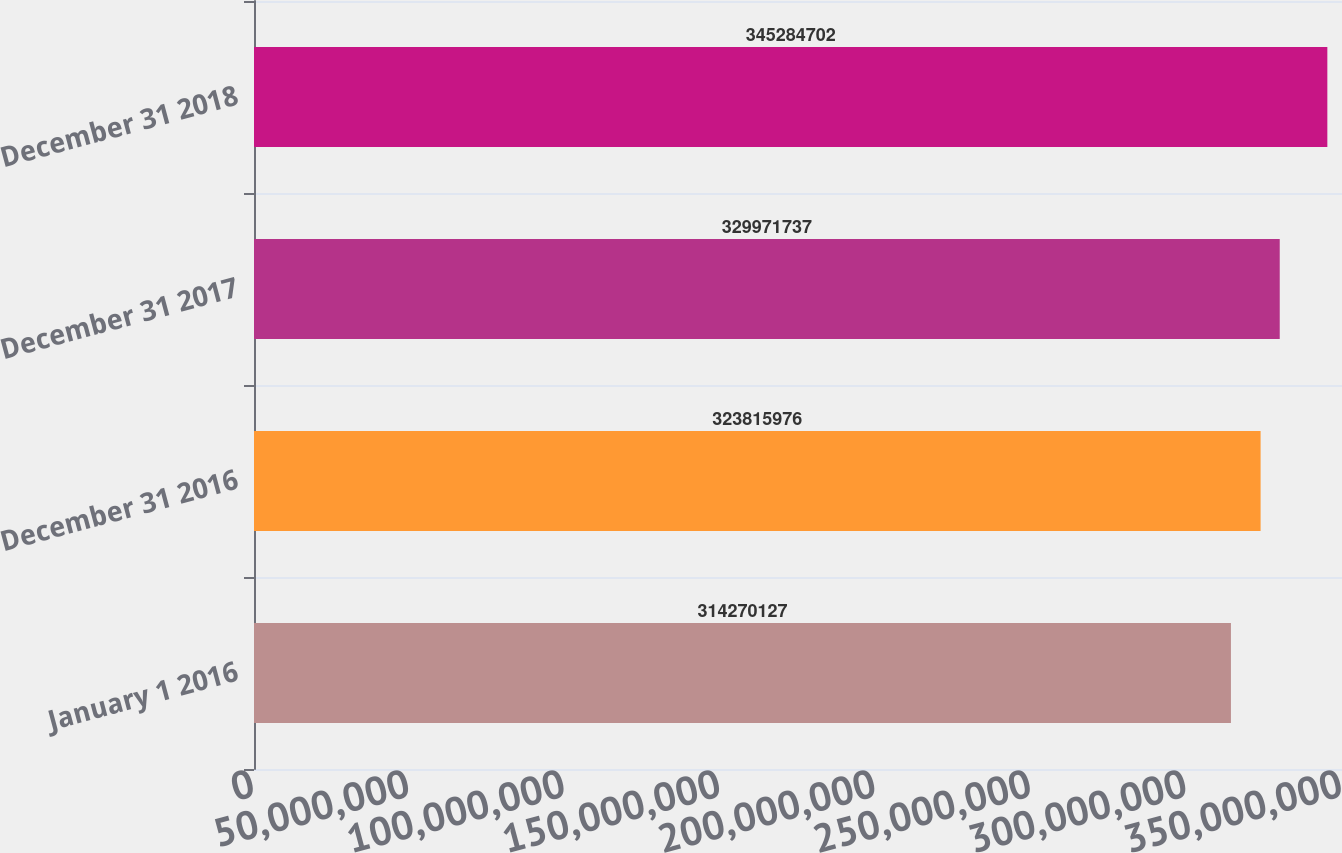Convert chart to OTSL. <chart><loc_0><loc_0><loc_500><loc_500><bar_chart><fcel>January 1 2016<fcel>December 31 2016<fcel>December 31 2017<fcel>December 31 2018<nl><fcel>3.1427e+08<fcel>3.23816e+08<fcel>3.29972e+08<fcel>3.45285e+08<nl></chart> 